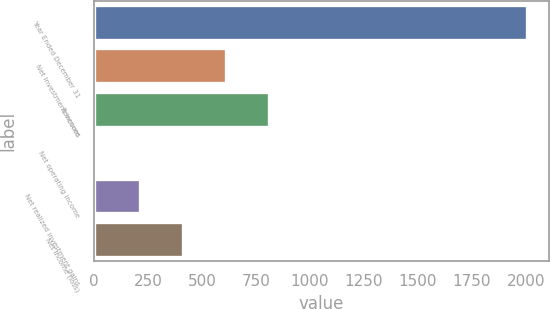<chart> <loc_0><loc_0><loc_500><loc_500><bar_chart><fcel>Year Ended December 31<fcel>Net investment income<fcel>Revenues<fcel>Net operating income<fcel>Net realized investment gains<fcel>Net income (loss)<nl><fcel>2006<fcel>611.6<fcel>810.8<fcel>14<fcel>213.2<fcel>412.4<nl></chart> 